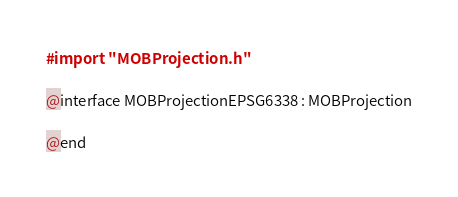Convert code to text. <code><loc_0><loc_0><loc_500><loc_500><_C_>#import "MOBProjection.h"

@interface MOBProjectionEPSG6338 : MOBProjection

@end
</code> 